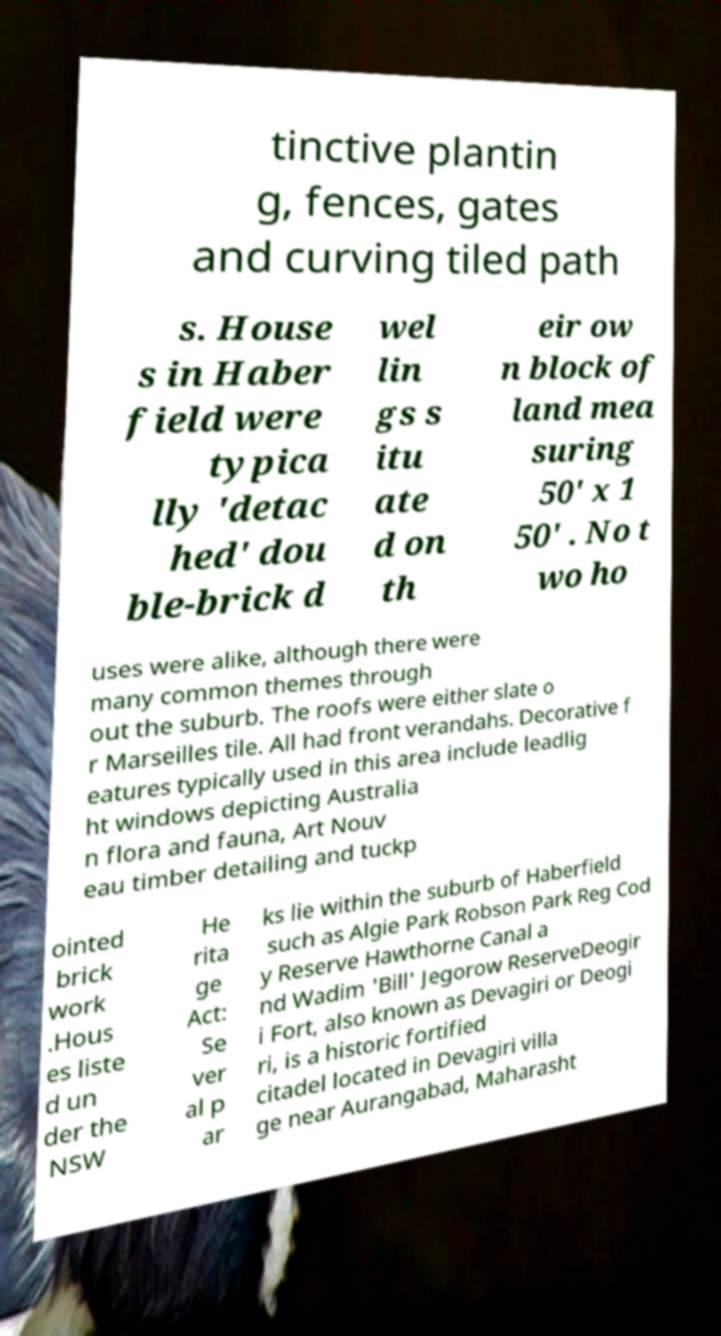Can you accurately transcribe the text from the provided image for me? tinctive plantin g, fences, gates and curving tiled path s. House s in Haber field were typica lly 'detac hed' dou ble-brick d wel lin gs s itu ate d on th eir ow n block of land mea suring 50' x 1 50' . No t wo ho uses were alike, although there were many common themes through out the suburb. The roofs were either slate o r Marseilles tile. All had front verandahs. Decorative f eatures typically used in this area include leadlig ht windows depicting Australia n flora and fauna, Art Nouv eau timber detailing and tuckp ointed brick work .Hous es liste d un der the NSW He rita ge Act: Se ver al p ar ks lie within the suburb of Haberfield such as Algie Park Robson Park Reg Cod y Reserve Hawthorne Canal a nd Wadim 'Bill' Jegorow ReserveDeogir i Fort, also known as Devagiri or Deogi ri, is a historic fortified citadel located in Devagiri villa ge near Aurangabad, Maharasht 